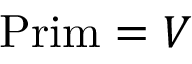Convert formula to latex. <formula><loc_0><loc_0><loc_500><loc_500>{ P r i m } = V \,</formula> 